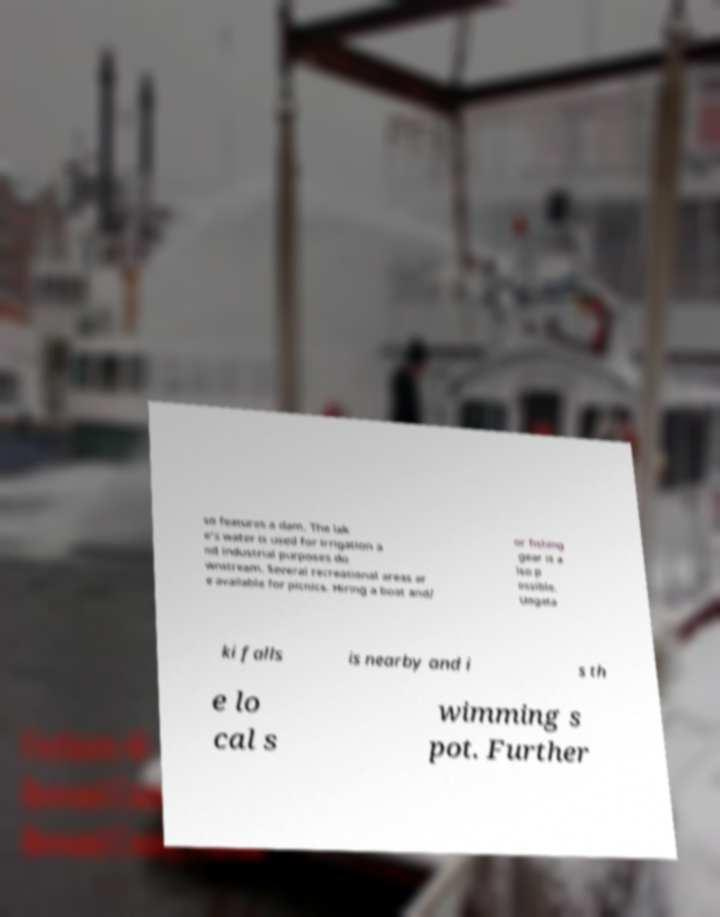For documentation purposes, I need the text within this image transcribed. Could you provide that? so features a dam. The lak e's water is used for irrigation a nd industrial purposes do wnstream. Several recreational areas ar e available for picnics. Hiring a boat and/ or fishing gear is a lso p ossible. Uogata ki falls is nearby and i s th e lo cal s wimming s pot. Further 